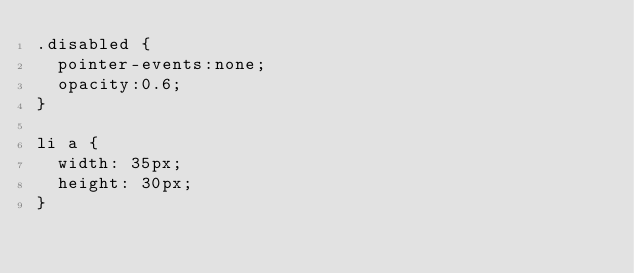Convert code to text. <code><loc_0><loc_0><loc_500><loc_500><_CSS_>.disabled {
  pointer-events:none;
  opacity:0.6;
}

li a {
  width: 35px;
  height: 30px;
}
</code> 